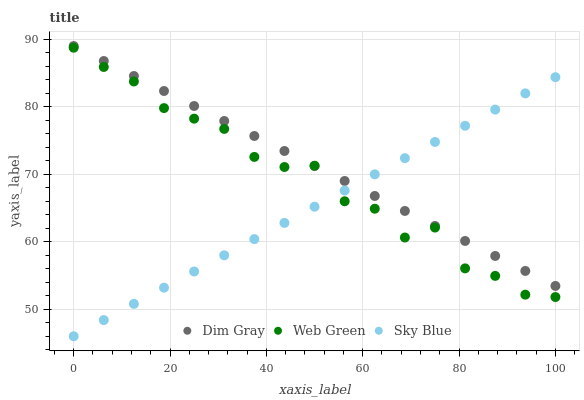Does Sky Blue have the minimum area under the curve?
Answer yes or no. Yes. Does Dim Gray have the maximum area under the curve?
Answer yes or no. Yes. Does Web Green have the minimum area under the curve?
Answer yes or no. No. Does Web Green have the maximum area under the curve?
Answer yes or no. No. Is Sky Blue the smoothest?
Answer yes or no. Yes. Is Web Green the roughest?
Answer yes or no. Yes. Is Dim Gray the smoothest?
Answer yes or no. No. Is Dim Gray the roughest?
Answer yes or no. No. Does Sky Blue have the lowest value?
Answer yes or no. Yes. Does Web Green have the lowest value?
Answer yes or no. No. Does Dim Gray have the highest value?
Answer yes or no. Yes. Does Web Green have the highest value?
Answer yes or no. No. Does Web Green intersect Dim Gray?
Answer yes or no. Yes. Is Web Green less than Dim Gray?
Answer yes or no. No. Is Web Green greater than Dim Gray?
Answer yes or no. No. 